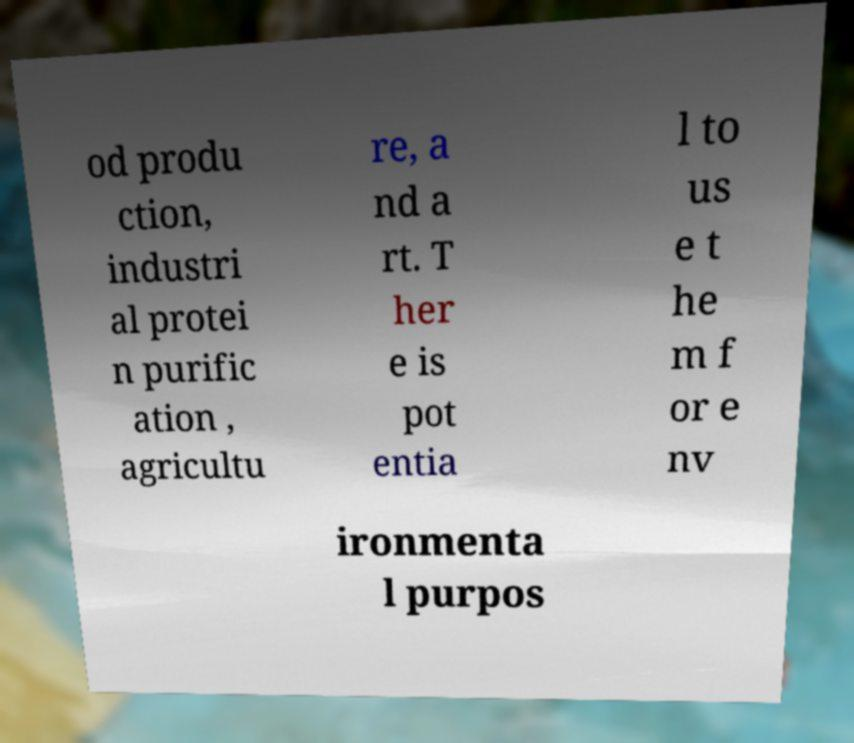There's text embedded in this image that I need extracted. Can you transcribe it verbatim? od produ ction, industri al protei n purific ation , agricultu re, a nd a rt. T her e is pot entia l to us e t he m f or e nv ironmenta l purpos 